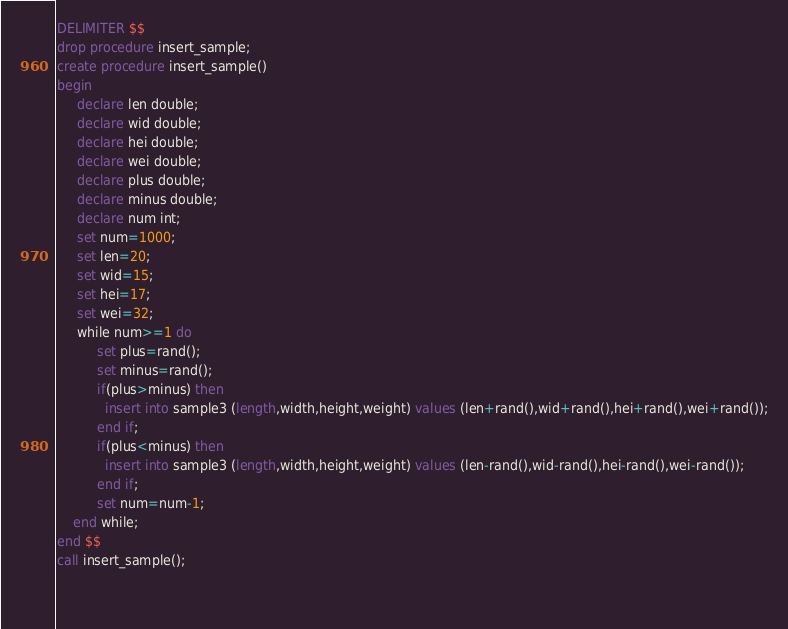<code> <loc_0><loc_0><loc_500><loc_500><_SQL_>DELIMITER $$
drop procedure insert_sample;
create procedure insert_sample()
begin
     declare len double;
     declare wid double;
     declare hei double;
     declare wei double;
     declare plus double;
     declare minus double;
     declare num int;
     set num=1000;
     set len=20;
     set wid=15;
     set hei=17;
     set wei=32;
     while num>=1 do
          set plus=rand();
          set minus=rand();
          if(plus>minus) then
			insert into sample3 (length,width,height,weight) values (len+rand(),wid+rand(),hei+rand(),wei+rand());
          end if;
          if(plus<minus) then
			insert into sample3 (length,width,height,weight) values (len-rand(),wid-rand(),hei-rand(),wei-rand());
          end if;
          set num=num-1;
	end while;
end $$
call insert_sample();
		
     </code> 